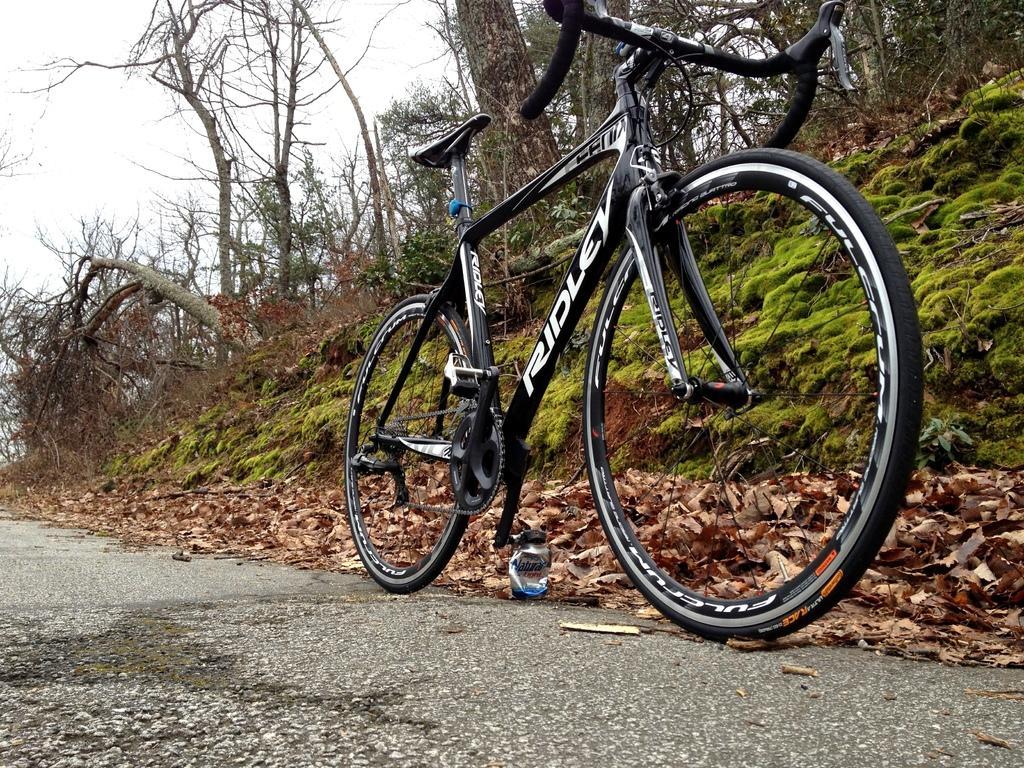How would you summarize this image in a sentence or two? In this picture I can observe a black color bicycle on the road. There are some dried leaves on the side of the road. I can observe some dried trees in this picture. In the background there is a sky. 